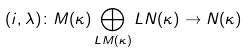Convert formula to latex. <formula><loc_0><loc_0><loc_500><loc_500>( i , \lambda ) \colon M ( \kappa ) \bigoplus _ { L M ( \kappa ) } L N ( \kappa ) \rightarrow N ( \kappa )</formula> 